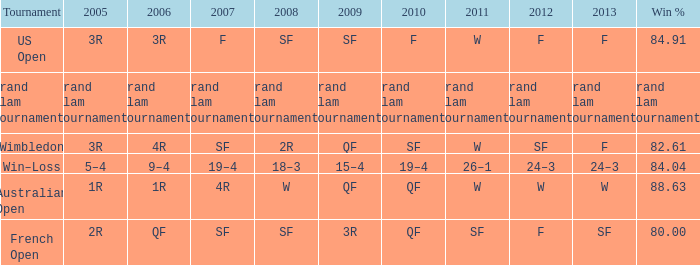When in 2008 that has a 2007 of f? SF. 